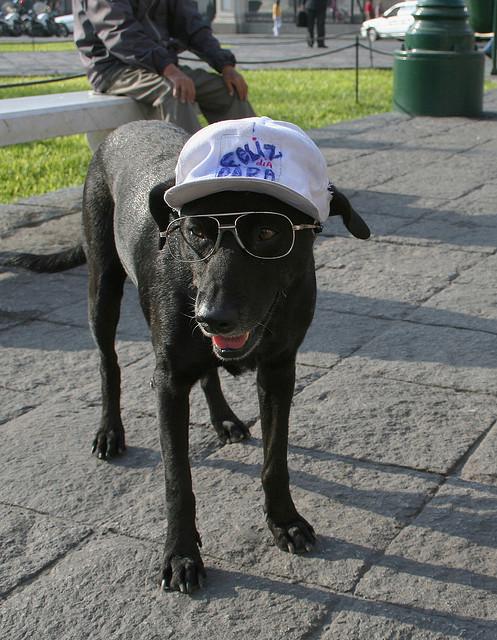What is the dog wearing?
Concise answer only. Hat. Are there human items on this dog?
Write a very short answer. Yes. What is around the grass?
Write a very short answer. Fence. 